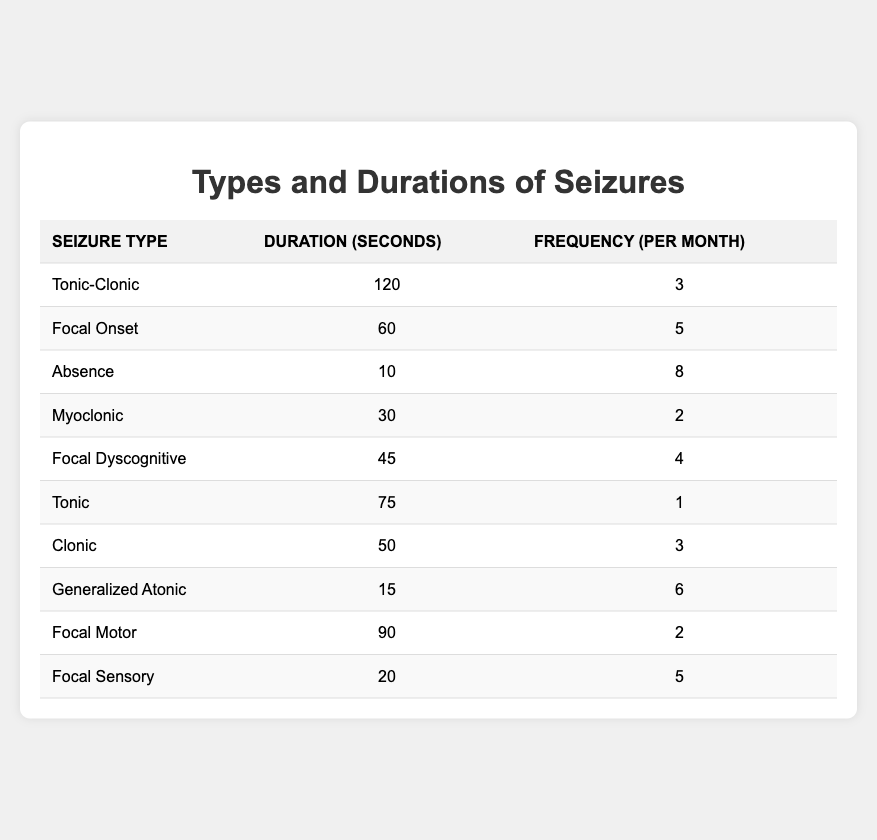What is the duration of a Tonic-Clonic seizure? The table lists the duration for Tonic-Clonic seizures as 120 seconds.
Answer: 120 seconds How many patients experienced Absence seizures? There is one entry in the table for Absence seizures, indicating one patient experienced this type.
Answer: 1 patient What seizure type has the longest duration? By comparing all duration values, Tonic-Clonic seizures last the longest at 120 seconds.
Answer: Tonic-Clonic What is the average duration of all seizures listed? To find the average, sum the durations: (120 + 60 + 10 + 30 + 45 + 75 + 50 + 15 + 90 + 20) = 600 seconds. There are 10 durations, so the average is 600/10 = 60 seconds.
Answer: 60 seconds Are there more patients experiencing Focal Onset seizures than Myoclonic seizures? Focal Onset seizures have 5 occurrences per month and Myoclonic seizures have 2 occurrences per month. This means more patients are likely experiencing Focal Onset seizures.
Answer: Yes What is the total frequency of all seizure types combined? By summing the frequency values: (3 + 5 + 8 + 2 + 4 + 1 + 3 + 6 + 2 + 5) = 39.
Answer: 39 Which seizure type occurs most frequently? Absence seizures occur 8 times a month, more than any other type listed in the table.
Answer: Absence What is the difference in duration between Focal Motor and Focal Onset seizures? The duration of Focal Motor seizures is 90 seconds, while Focal Onset seizures last 60 seconds. The difference is 90 - 60 = 30 seconds.
Answer: 30 seconds What percentage of the seizures are Focal types? There are three Focal types: Focal Onset, Focal Dyscognitive, and Focal Motor, a total of 3 out of 10 types, so (3/10)*100 = 30%.
Answer: 30% How many patients have seizures lasting less than 30 seconds? The only seizure type lasting less than 30 seconds is Absence at 10 seconds, so there's only one patient.
Answer: 1 patient 